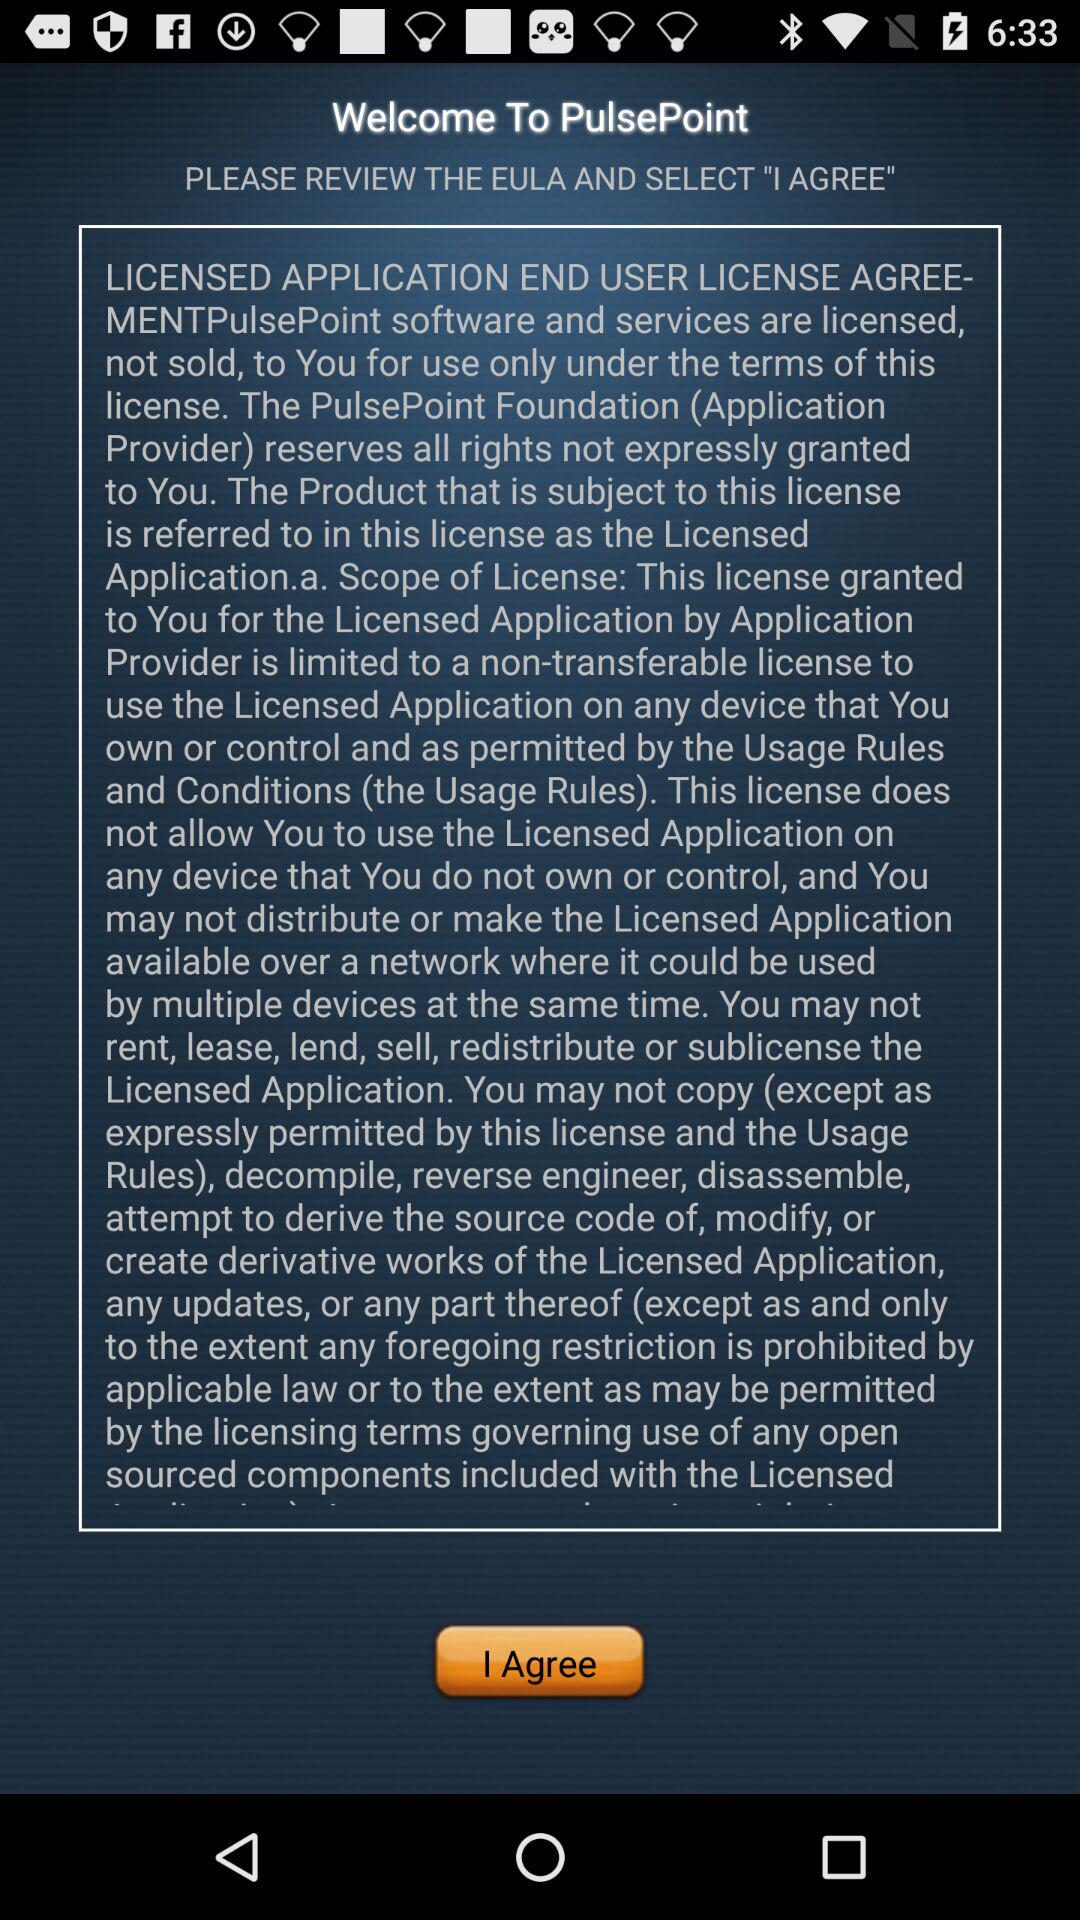Which version of the application is this?
When the provided information is insufficient, respond with <no answer>. <no answer> 